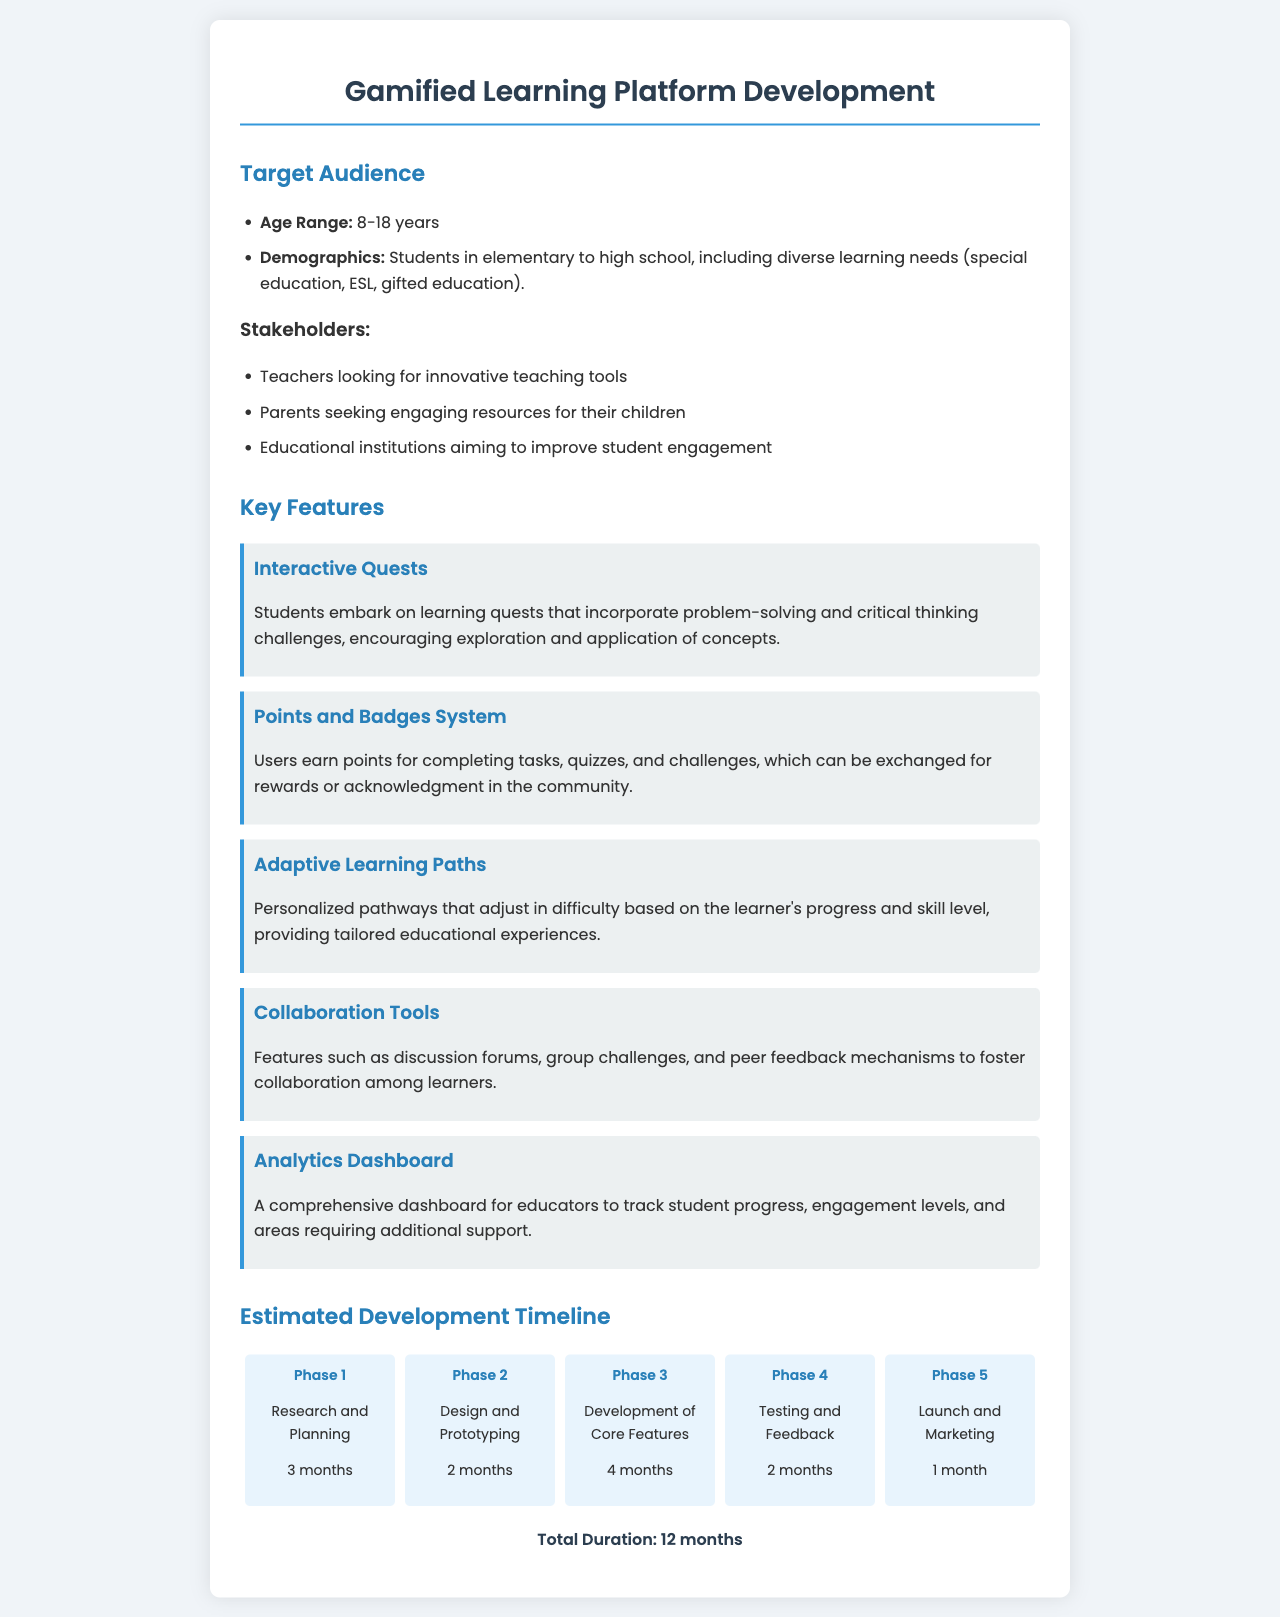What is the age range of the target audience? The age range of the target audience is explicitly stated in the document as 8-18 years.
Answer: 8-18 years Who are the stakeholders mentioned? The document lists stakeholders including teachers, parents, and educational institutions; these are key individuals or groups involved.
Answer: Teachers, Parents, Educational institutions What is the estimated total duration for the development? The total duration is calculated based on the phases in the document, which sums up to 12 months.
Answer: 12 months How many months are allocated for testing and feedback? The document specifies the duration for testing and feedback as 2 months, which is part of the timeline.
Answer: 2 months What feature incorporates problem-solving challenges? The feature that includes problem-solving challenges is described as Interactive Quests in the document.
Answer: Interactive Quests Which phase involves design and prototyping? The phase that is concerned with design and prototyping is specifically labeled as Phase 2 in the timeline.
Answer: Phase 2 What reward system is mentioned in the key features? The document refers to a Points and Badges System that recognizes user achievements.
Answer: Points and Badges System What percentage of the document covers the target audience? The target audience section comprises approximately 10 percent of the overall document structure, with a total of roughly 30 sections overall.
Answer: Approximately 10 percent 